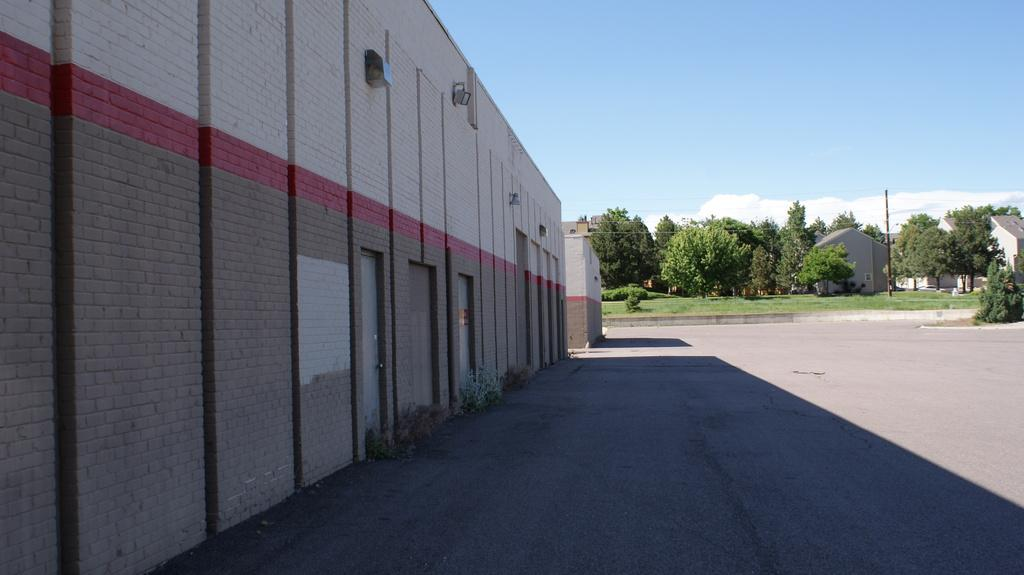What structure is located on the left side of the image? There is a building on the left side of the image. What type of architectural features can be seen in the image? There are doors and lamps visible in the image. What type of natural environment is present in the image? There is grass in the image, and trees, plants, and grass can be seen in the background. What is visible in the sky in the background of the image? The sky is visible in the background of the image, with clouds present. What type of man-made structures can be seen in the background of the image? There are buildings and poles visible in the background of the image. What type of road is present in the background of the image? There is a road in the background of the image. What type of stamp can be seen on the head of the nut in the image? There is no stamp, head, or nut present in the image. 